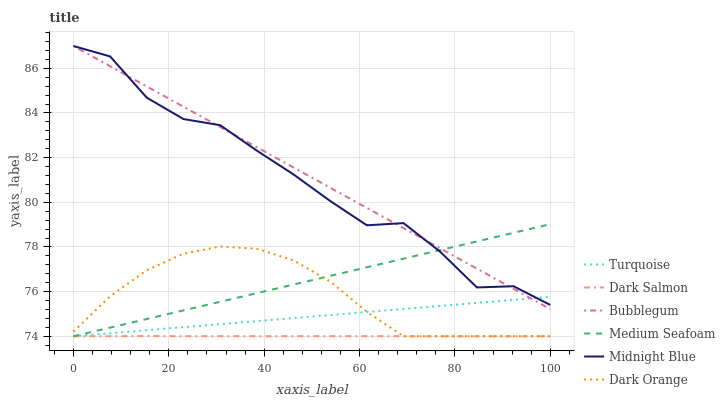Does Dark Salmon have the minimum area under the curve?
Answer yes or no. Yes. Does Bubblegum have the maximum area under the curve?
Answer yes or no. Yes. Does Turquoise have the minimum area under the curve?
Answer yes or no. No. Does Turquoise have the maximum area under the curve?
Answer yes or no. No. Is Medium Seafoam the smoothest?
Answer yes or no. Yes. Is Midnight Blue the roughest?
Answer yes or no. Yes. Is Turquoise the smoothest?
Answer yes or no. No. Is Turquoise the roughest?
Answer yes or no. No. Does Dark Orange have the lowest value?
Answer yes or no. Yes. Does Midnight Blue have the lowest value?
Answer yes or no. No. Does Bubblegum have the highest value?
Answer yes or no. Yes. Does Turquoise have the highest value?
Answer yes or no. No. Is Dark Salmon less than Bubblegum?
Answer yes or no. Yes. Is Bubblegum greater than Dark Salmon?
Answer yes or no. Yes. Does Medium Seafoam intersect Midnight Blue?
Answer yes or no. Yes. Is Medium Seafoam less than Midnight Blue?
Answer yes or no. No. Is Medium Seafoam greater than Midnight Blue?
Answer yes or no. No. Does Dark Salmon intersect Bubblegum?
Answer yes or no. No. 